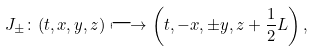<formula> <loc_0><loc_0><loc_500><loc_500>J _ { \pm } \colon ( t , x , y , z ) \longmapsto \left ( t , - x , \pm y , z + \frac { 1 } { 2 } L \right ) ,</formula> 